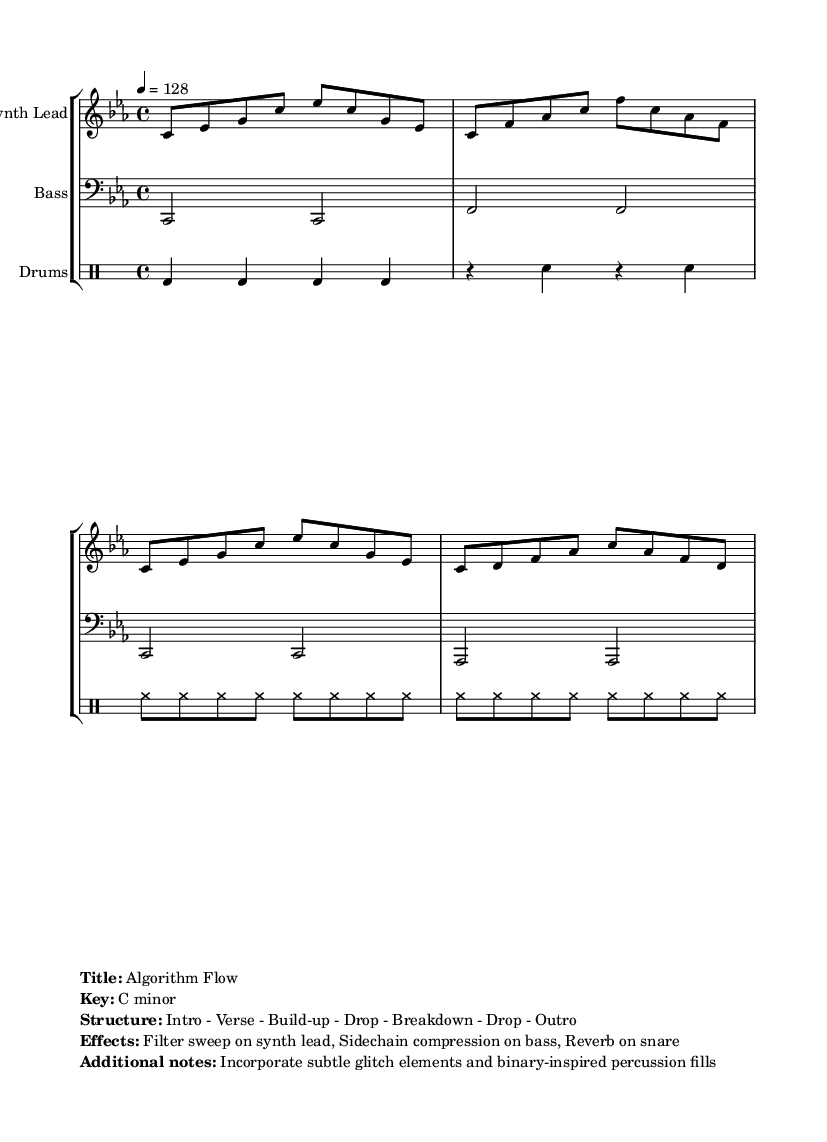What is the key signature of this music? The key signature is indicated at the beginning of the staff and shows a flat on the B note. This means the music is in C minor, which has three flats (B♭, E♭, A♭) but only the B♭ is explicitly shown.
Answer: C minor What is the time signature of this music? The time signature appears near the beginning of the staff and is shown as 4/4. This indicates that there are 4 beats in each measure and a quarter note gets one beat.
Answer: 4/4 What is the tempo marking for this track? The tempo marking, indicated within the score, states "4 = 128," meaning that a quarter note is played at 128 beats per minute. This is a typical tempo for upbeat house music.
Answer: 128 How many bars are in the synth lead part? To find the number of bars, count the number of measures indicated by vertical lines in the staff. There are 8 measures in the synth lead part as per the section provided.
Answer: 8 What type of ensemble is featured in this music? The score includes a staff group with three different parts: Synth Lead, Bass, and Drums. This setup is typical for electronic music and house tracks to provide a full sound with both melodic and rhythmic components.
Answer: Ensemble with Synth Lead, Bass, and Drums What is the structure of the track? The structure is detailed in the markup section at the bottom of the score, listing it as "Intro - Verse - Build-up - Drop - Breakdown - Drop - Outro". This suggests a familiar arrangement in house music designed to create energy and tension.
Answer: Intro - Verse - Build-up - Drop - Breakdown - Drop - Outro What specific effects are mentioned for this track? The effects indicated in the markup section specify a filter sweep on the synth lead, sidechain compression on bass, and reverb on the snare. These effects contribute to the overall sound typical in house music production.
Answer: Filter sweep, Sidechain compression, Reverb 